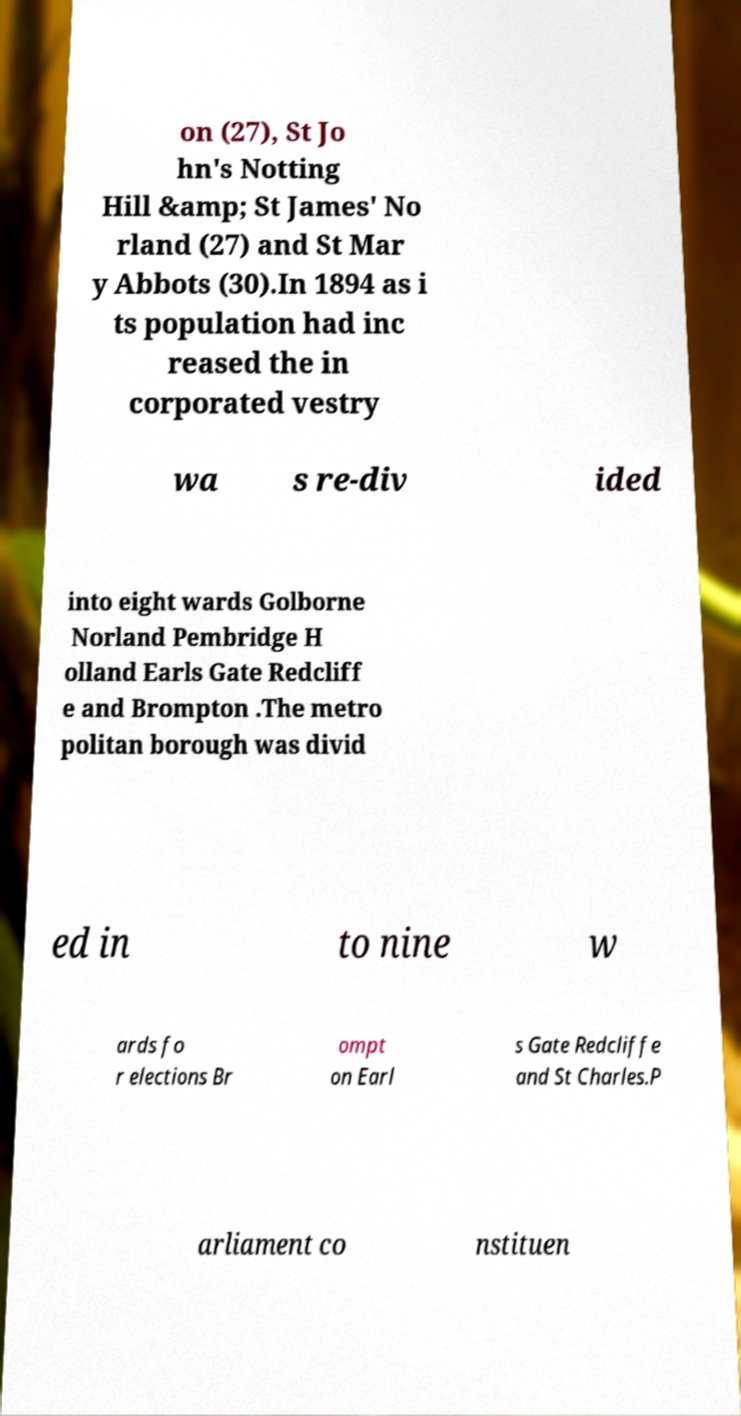There's text embedded in this image that I need extracted. Can you transcribe it verbatim? on (27), St Jo hn's Notting Hill &amp; St James' No rland (27) and St Mar y Abbots (30).In 1894 as i ts population had inc reased the in corporated vestry wa s re-div ided into eight wards Golborne Norland Pembridge H olland Earls Gate Redcliff e and Brompton .The metro politan borough was divid ed in to nine w ards fo r elections Br ompt on Earl s Gate Redcliffe and St Charles.P arliament co nstituen 